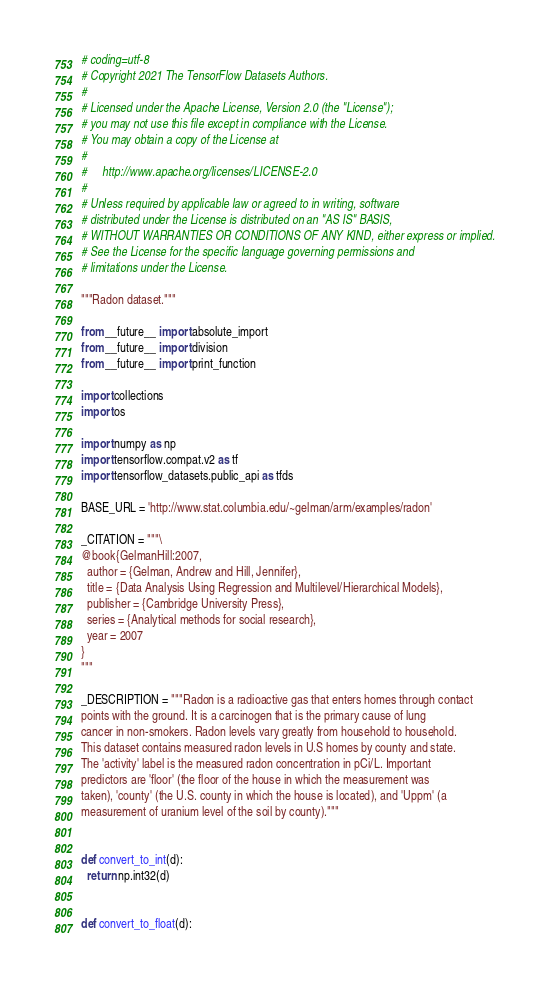Convert code to text. <code><loc_0><loc_0><loc_500><loc_500><_Python_># coding=utf-8
# Copyright 2021 The TensorFlow Datasets Authors.
#
# Licensed under the Apache License, Version 2.0 (the "License");
# you may not use this file except in compliance with the License.
# You may obtain a copy of the License at
#
#     http://www.apache.org/licenses/LICENSE-2.0
#
# Unless required by applicable law or agreed to in writing, software
# distributed under the License is distributed on an "AS IS" BASIS,
# WITHOUT WARRANTIES OR CONDITIONS OF ANY KIND, either express or implied.
# See the License for the specific language governing permissions and
# limitations under the License.

"""Radon dataset."""

from __future__ import absolute_import
from __future__ import division
from __future__ import print_function

import collections
import os

import numpy as np
import tensorflow.compat.v2 as tf
import tensorflow_datasets.public_api as tfds

BASE_URL = 'http://www.stat.columbia.edu/~gelman/arm/examples/radon'

_CITATION = """\
@book{GelmanHill:2007,
  author = {Gelman, Andrew and Hill, Jennifer},
  title = {Data Analysis Using Regression and Multilevel/Hierarchical Models},
  publisher = {Cambridge University Press},
  series = {Analytical methods for social research},
  year = 2007
}
"""

_DESCRIPTION = """Radon is a radioactive gas that enters homes through contact
points with the ground. It is a carcinogen that is the primary cause of lung
cancer in non-smokers. Radon levels vary greatly from household to household.
This dataset contains measured radon levels in U.S homes by county and state.
The 'activity' label is the measured radon concentration in pCi/L. Important
predictors are 'floor' (the floor of the house in which the measurement was
taken), 'county' (the U.S. county in which the house is located), and 'Uppm' (a
measurement of uranium level of the soil by county)."""


def convert_to_int(d):
  return np.int32(d)


def convert_to_float(d):</code> 